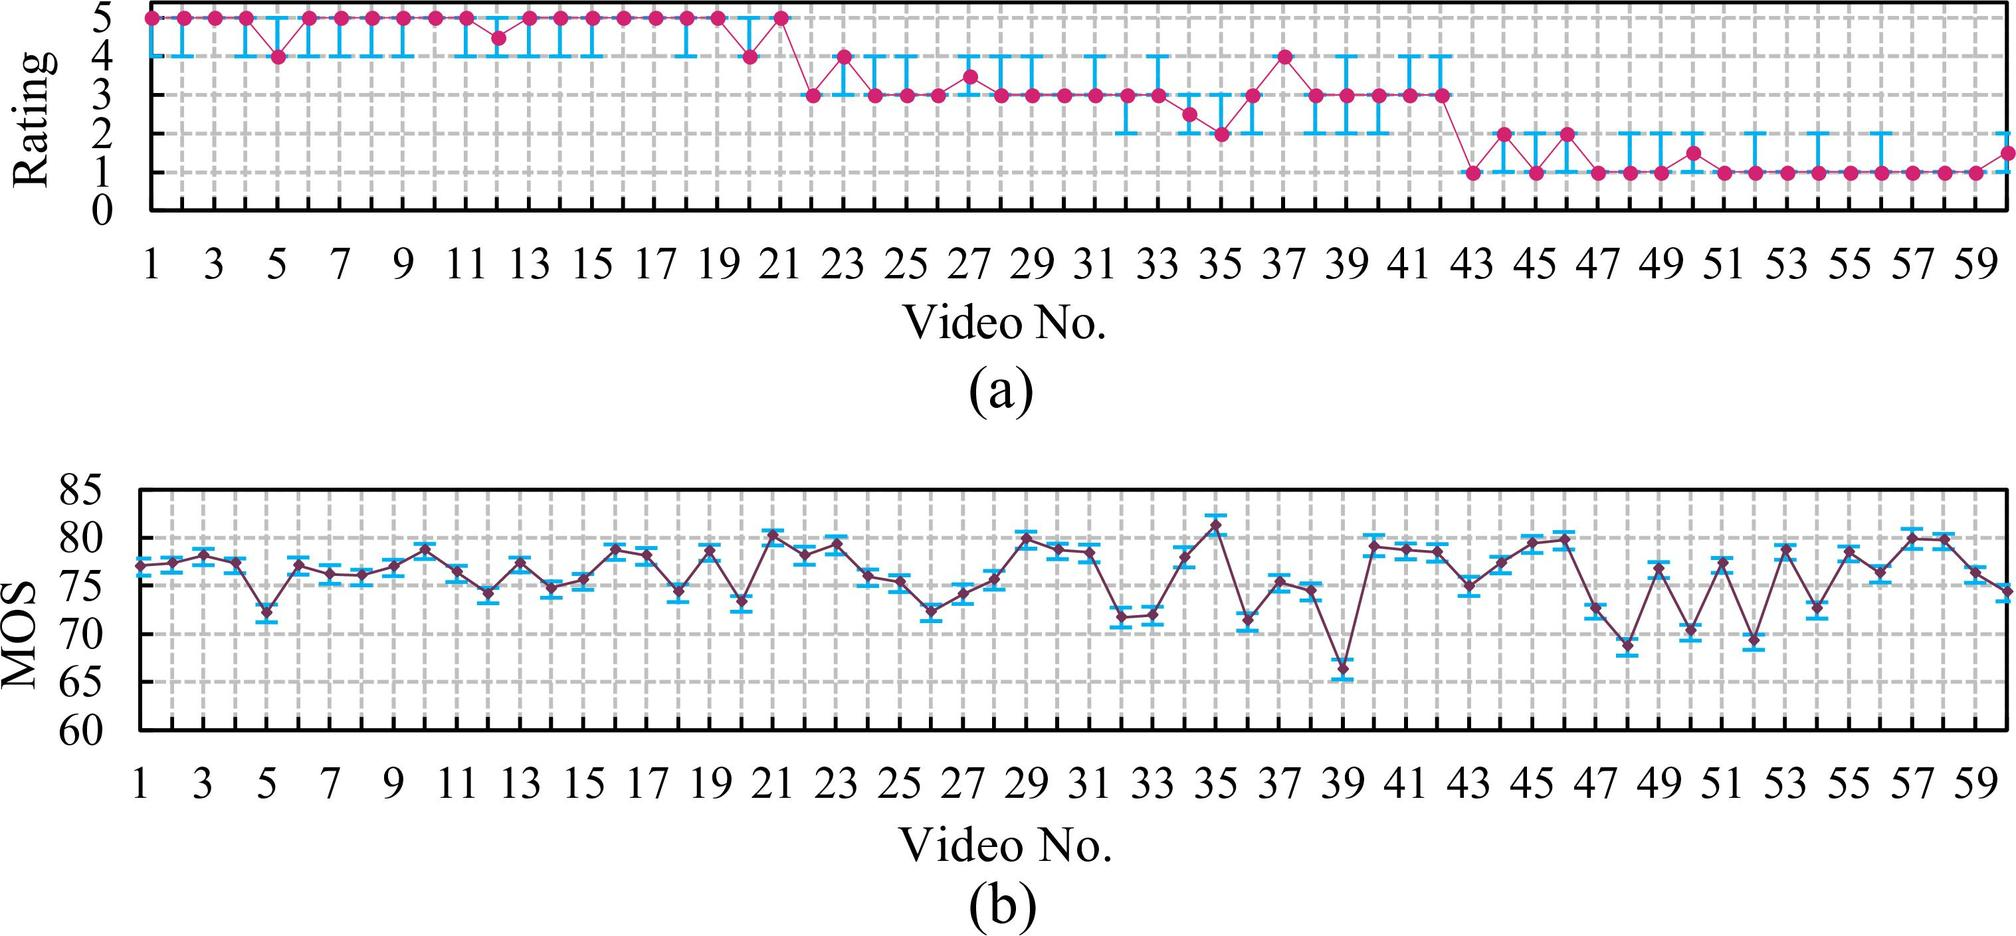What trend is observed in the ratings given to the videos in graph (a)? A. The ratings increase as the video number increases. B. The ratings remain constant throughout. C. The ratings decrease as the video number increases. D. The ratings fluctuate but overall remain around the same average. The graph shows fluctuations in the ratings given to different videos. While there are ups and downs, the ratings hover around the same average value, indicating no significant increase or decrease over the video numbers. Therefore, the correct answer is D. 